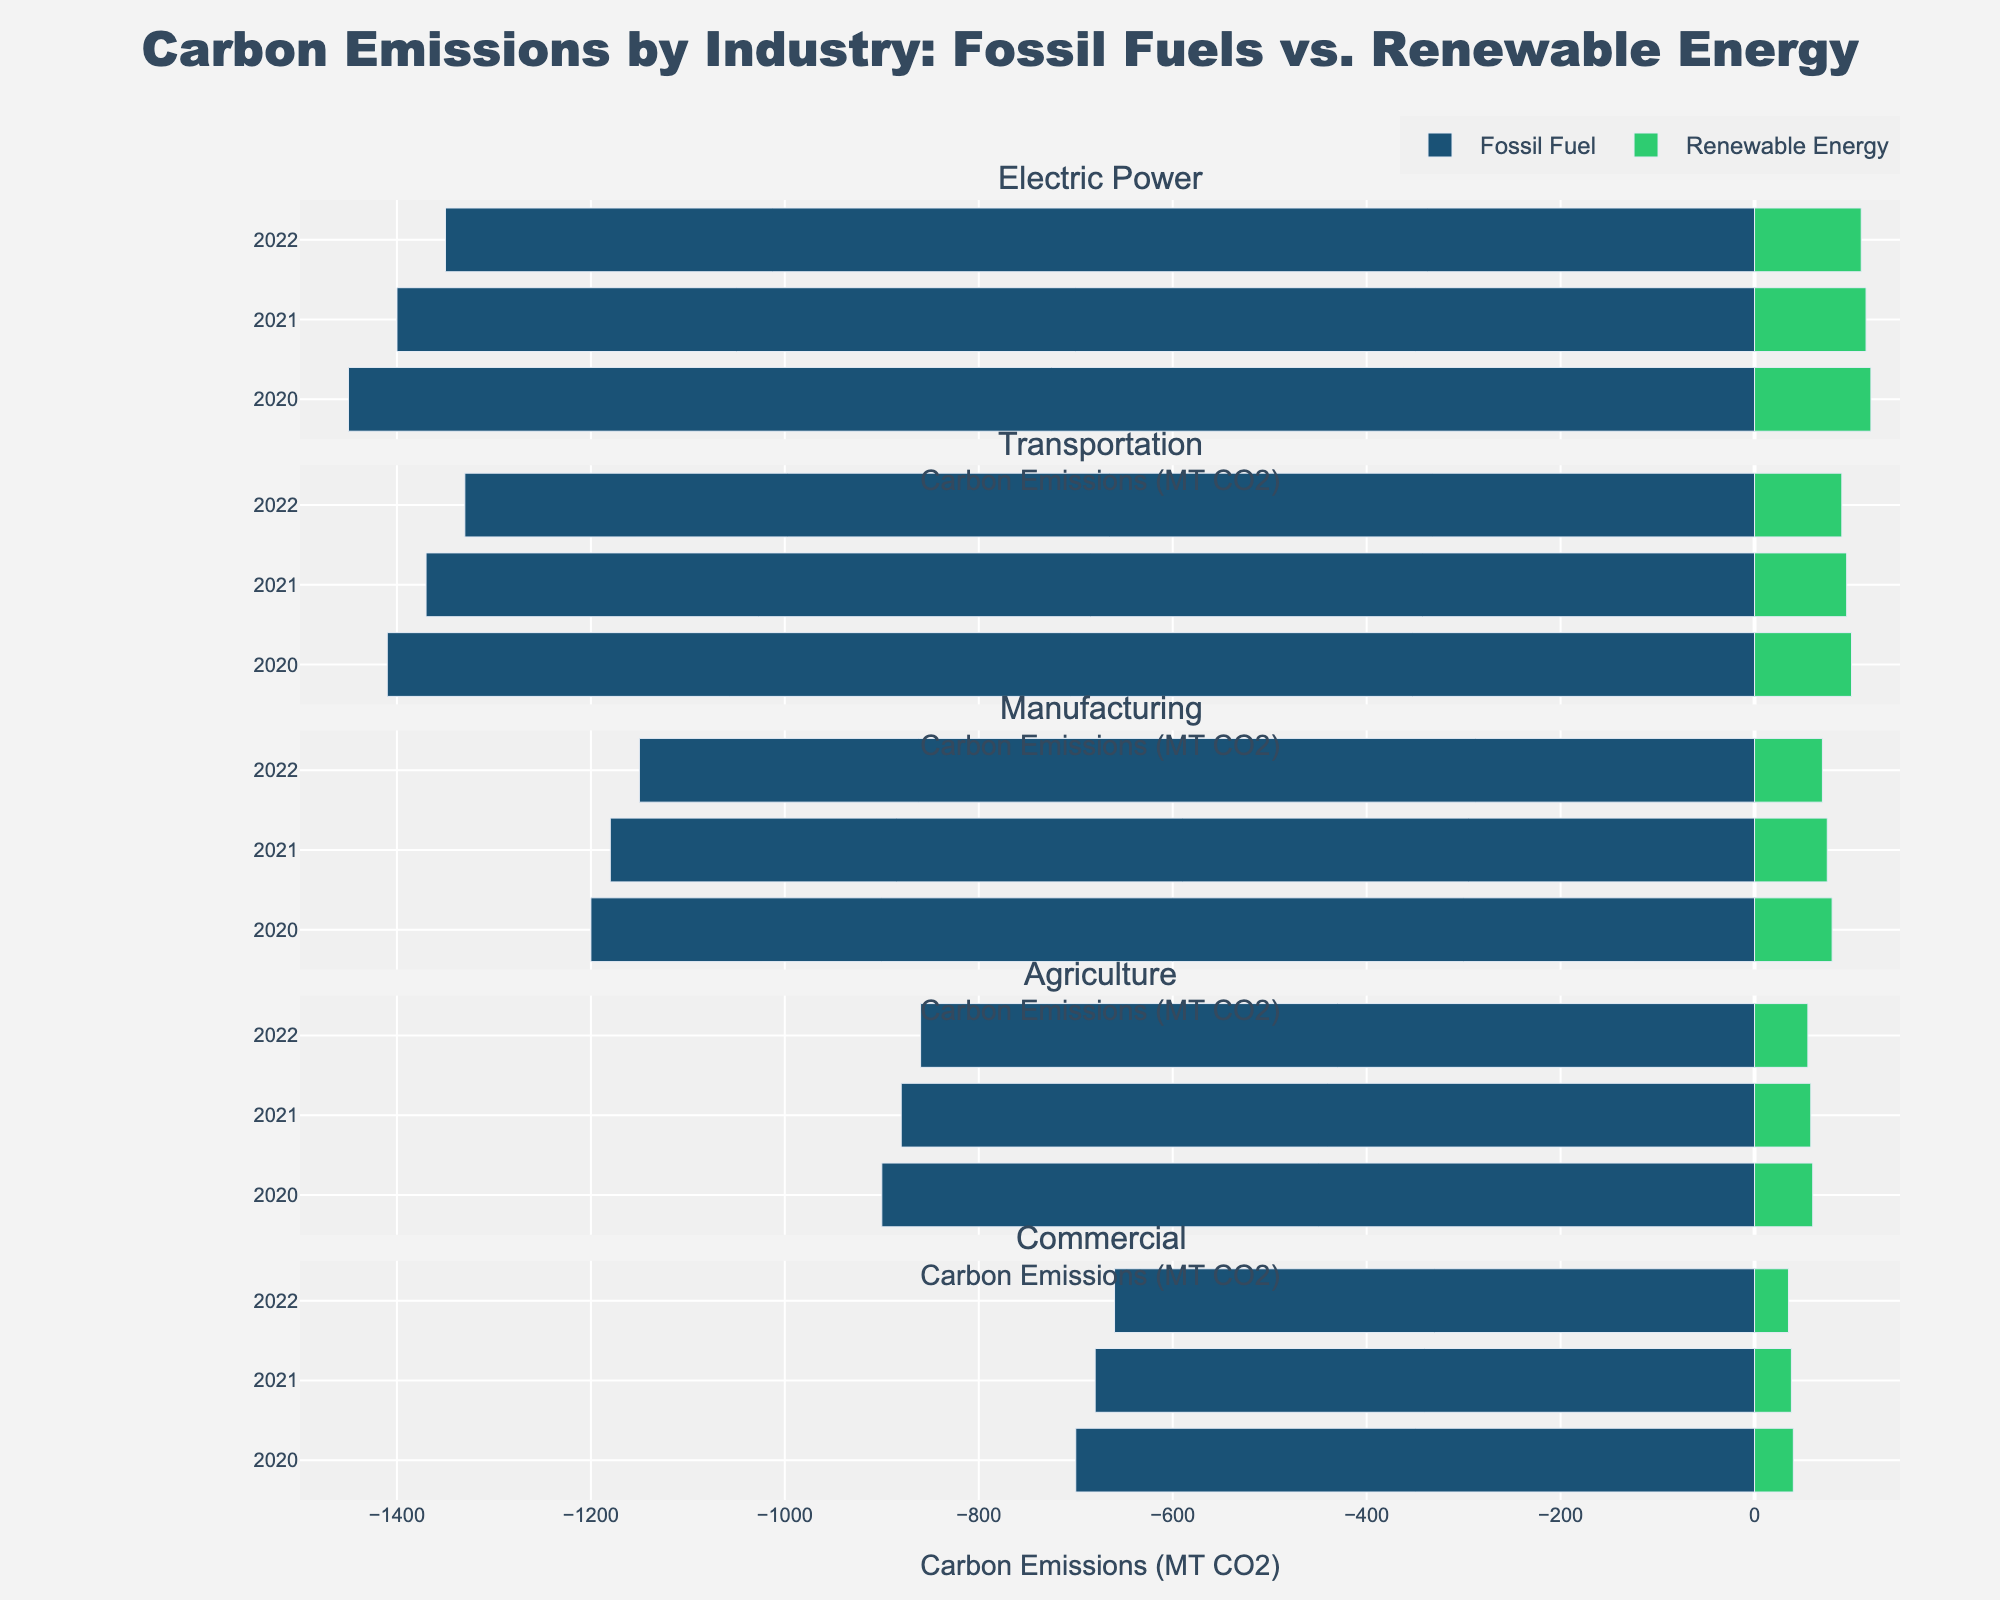What's the difference in fossil fuel emissions by the Electric Power industry between 2020 and 2022? Look at the length of the bars representing fossil fuel emissions for Electric Power in 2020 and 2022. In 2020, the emission is 1450 MT CO2, and in 2022, it is 1350 MT CO2. The difference is 1450 - 1350 = 100 MT CO2.
Answer: 100 MT CO2 Which industry had the lowest renewable energy emissions in 2022? Compare the lengths of the bars representing renewable energy emissions for each industry in 2022. The Commercial industry had the smallest bar length, which indicates the lowest emissions of 35 MT CO2.
Answer: Commercial Has there been a decrease or increase in fossil fuel emissions in the Transportation industry from 2020 to 2022? Examine the length of the bars representing Transportation's fossil fuel emissions from 2020 to 2022. The lengths decrease from 1410 MT CO2 in 2020 to 1330 MT CO2 in 2022, indicating a decrease.
Answer: Decrease What is the total renewable energy emission for all industries in 2021? Sum the lengths of the bars for renewable energy emissions across all industries in 2021. Renewable energy emissions in 2021 are: Electric Power 115 MT CO2, Transportation 95 MT CO2, Manufacturing 75 MT CO2, Agriculture 58 MT CO2, Commercial 38 MT CO2. The total is 115 + 95 + 75 + 58 + 38 = 381 MT CO2.
Answer: 381 MT CO2 How do the fossil fuel emissions of the Manufacturing industry in 2021 compare with those of Agriculture in the same year? Compare the lengths of the bars representing fossil fuel emissions for the Manufacturing and Agriculture industries in 2021. Manufacturing's bar shows 1180 MT CO2, while Agriculture's bar shows 880 MT CO2. Manufacturing has higher emissions.
Answer: Manufacturing is higher What is the average fossil fuel emission from the Electric Power industry over the three years shown? Calculate the average by summing the fossil fuel emissions for Electric Power from 2020 to 2022 and then dividing by 3: (1450 + 1400 + 1350) / 3 = 4200 / 3 = 1400 MT CO2.
Answer: 1400 MT CO2 Which industry's fossil fuel emissions saw the greatest percentage decrease from 2020 to 2022? Calculate the percentage decrease for each industry: 
- Electric Power: (1450 - 1350) / 1450 * 100 = 6.9%
- Transportation: (1410 - 1330) / 1410 * 100 = 5.7%
- Manufacturing: (1200 - 1150) / 1200 * 100 = 4.2%
- Agriculture: (900 - 860) / 900 * 100 = 4.4%
- Commercial: (700 - 660) / 700 * 100 = 5.7%
Electric Power saw the greatest percentage decrease of 6.9%.
Answer: Electric Power Which sector shows the most significant difference between fossil fuel and renewable energy emissions in 2020? Compare the differences between the lengths of the fossil fuel and renewable energy bars for each sector in 2020: 
- Electric Power: 1450 - 120 = 1330 MT CO2
- Transportation: 1410 - 100 = 1310 MT CO2
- Manufacturing: 1200 - 80 = 1120 MT CO2
- Agriculture: 900 - 60 = 840 MT CO2
- Commercial: 700 - 40 = 660 MT CO2
Electric Power has the largest difference of 1330 MT CO2.
Answer: Electric Power 